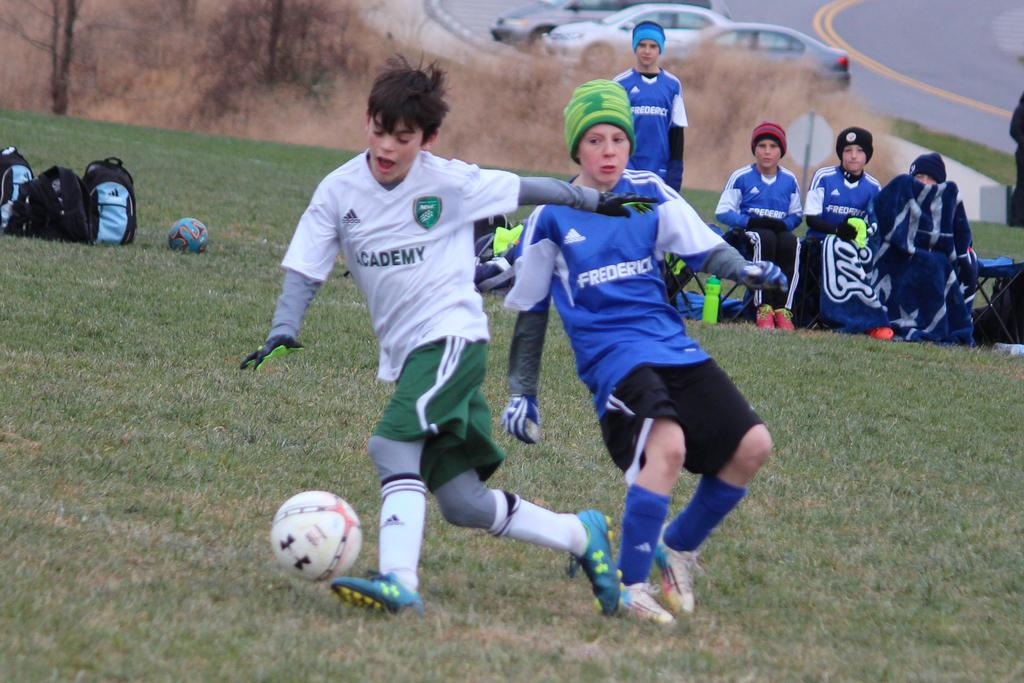<image>
Create a compact narrative representing the image presented. The player from Academy keeps the ball away from the Frederick player. 